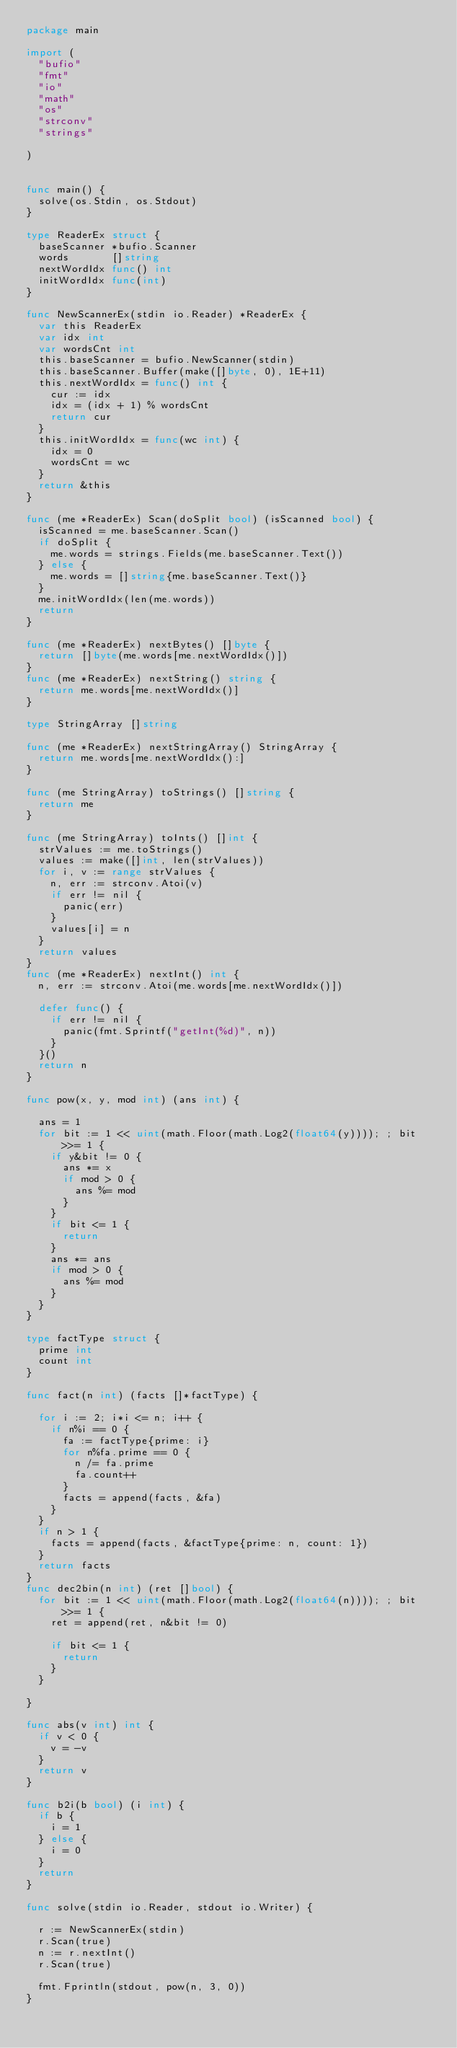Convert code to text. <code><loc_0><loc_0><loc_500><loc_500><_Go_>package main

import (
	"bufio"
	"fmt"
	"io"
	"math"
	"os"
	"strconv"
	"strings"

)


func main() {
	solve(os.Stdin, os.Stdout)
}

type ReaderEx struct {
	baseScanner *bufio.Scanner
	words       []string
	nextWordIdx func() int
	initWordIdx func(int)
}

func NewScannerEx(stdin io.Reader) *ReaderEx {
	var this ReaderEx
	var idx int
	var wordsCnt int
	this.baseScanner = bufio.NewScanner(stdin)
	this.baseScanner.Buffer(make([]byte, 0), 1E+11)
	this.nextWordIdx = func() int {
		cur := idx
		idx = (idx + 1) % wordsCnt
		return cur
	}
	this.initWordIdx = func(wc int) {
		idx = 0
		wordsCnt = wc
	}
	return &this
}

func (me *ReaderEx) Scan(doSplit bool) (isScanned bool) {
	isScanned = me.baseScanner.Scan()
	if doSplit {
		me.words = strings.Fields(me.baseScanner.Text())
	} else {
		me.words = []string{me.baseScanner.Text()}
	}
	me.initWordIdx(len(me.words))
	return
}

func (me *ReaderEx) nextBytes() []byte {
	return []byte(me.words[me.nextWordIdx()])
}
func (me *ReaderEx) nextString() string {
	return me.words[me.nextWordIdx()]
}

type StringArray []string

func (me *ReaderEx) nextStringArray() StringArray {
	return me.words[me.nextWordIdx():]
}

func (me StringArray) toStrings() []string {
	return me
}

func (me StringArray) toInts() []int {
	strValues := me.toStrings()
	values := make([]int, len(strValues))
	for i, v := range strValues {
		n, err := strconv.Atoi(v)
		if err != nil {
			panic(err)
		}
		values[i] = n
	}
	return values
}
func (me *ReaderEx) nextInt() int {
	n, err := strconv.Atoi(me.words[me.nextWordIdx()])

	defer func() {
		if err != nil {
			panic(fmt.Sprintf("getInt(%d)", n))
		}
	}()
	return n
}

func pow(x, y, mod int) (ans int) {

	ans = 1
	for bit := 1 << uint(math.Floor(math.Log2(float64(y)))); ; bit >>= 1 {
		if y&bit != 0 {
			ans *= x
			if mod > 0 {
				ans %= mod
			}
		}
		if bit <= 1 {
			return
		}
		ans *= ans
		if mod > 0 {
			ans %= mod
		}
	}
}

type factType struct {
	prime int
	count int
}

func fact(n int) (facts []*factType) {

	for i := 2; i*i <= n; i++ {
		if n%i == 0 {
			fa := factType{prime: i}
			for n%fa.prime == 0 {
				n /= fa.prime
				fa.count++
			}
			facts = append(facts, &fa)
		}
	}
	if n > 1 {
		facts = append(facts, &factType{prime: n, count: 1})
	}
	return facts
}
func dec2bin(n int) (ret []bool) {
	for bit := 1 << uint(math.Floor(math.Log2(float64(n)))); ; bit >>= 1 {
		ret = append(ret, n&bit != 0)

		if bit <= 1 {
			return
		}
	}

}

func abs(v int) int {
	if v < 0 {
		v = -v
	}
	return v
}

func b2i(b bool) (i int) {
	if b {
		i = 1
	} else {
		i = 0
	}
	return
}

func solve(stdin io.Reader, stdout io.Writer) {

	r := NewScannerEx(stdin)
	r.Scan(true)
	n := r.nextInt()
	r.Scan(true)

	fmt.Fprintln(stdout, pow(n, 3, 0))
}
</code> 